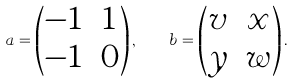Convert formula to latex. <formula><loc_0><loc_0><loc_500><loc_500>a = \left ( \begin{matrix} - 1 & 1 \\ - 1 & 0 \end{matrix} \right ) , \quad b = \left ( \begin{matrix} v & x \\ y & w \end{matrix} \right ) .</formula> 